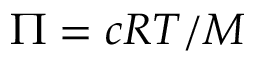Convert formula to latex. <formula><loc_0><loc_0><loc_500><loc_500>\Pi = c R T / M</formula> 